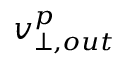Convert formula to latex. <formula><loc_0><loc_0><loc_500><loc_500>v _ { \perp , o u t } ^ { p }</formula> 